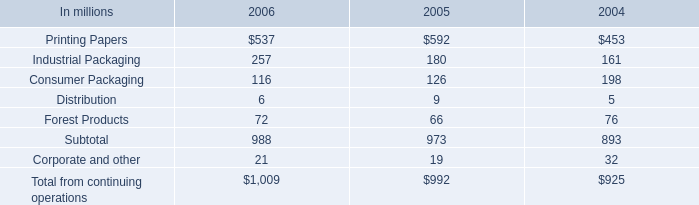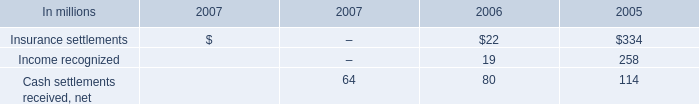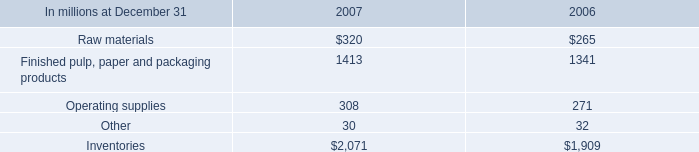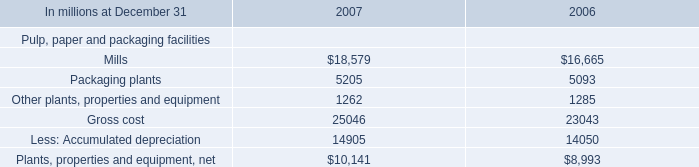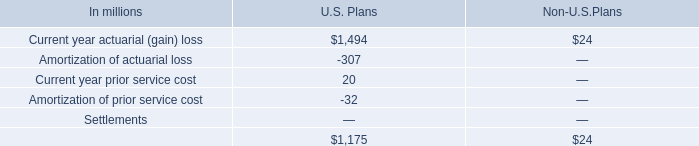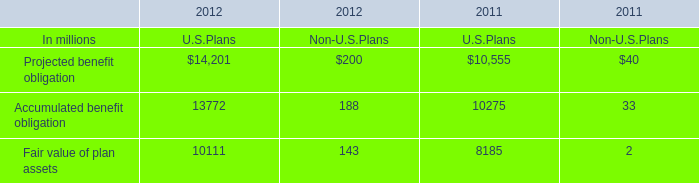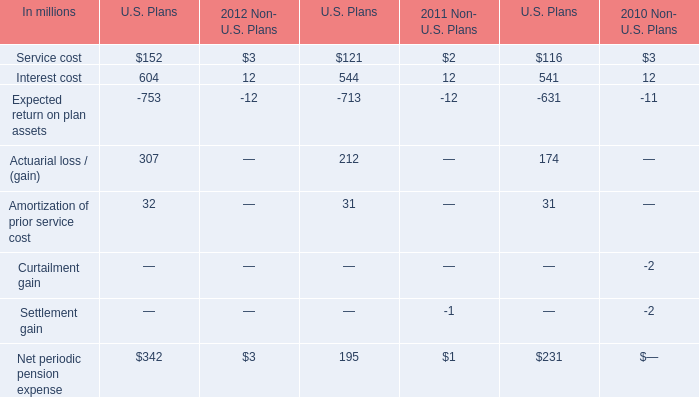what was the difference in the increase in the cash in working capital in 2006 compared with the increase in 2005 in millions 
Computations: (354 - 558)
Answer: -204.0. 